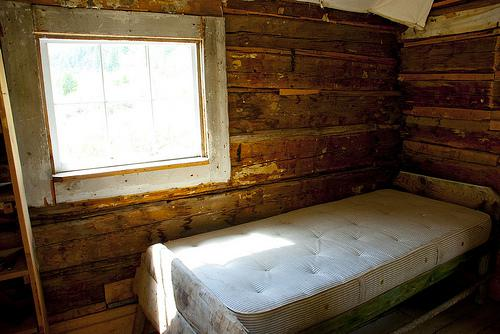Question: where was the photo taken?
Choices:
A. In a cabin.
B. At the zoo.
C. In the school bus.
D. At the ice cream parlor.
Answer with the letter. Answer: A Question: what are the walls are made of?
Choices:
A. Wood.
B. Cement.
C. Marble.
D. Paper.
Answer with the letter. Answer: A Question: what is in the room?
Choices:
A. Cabinet.
B. Television.
C. Chairs.
D. Bed.
Answer with the letter. Answer: D 